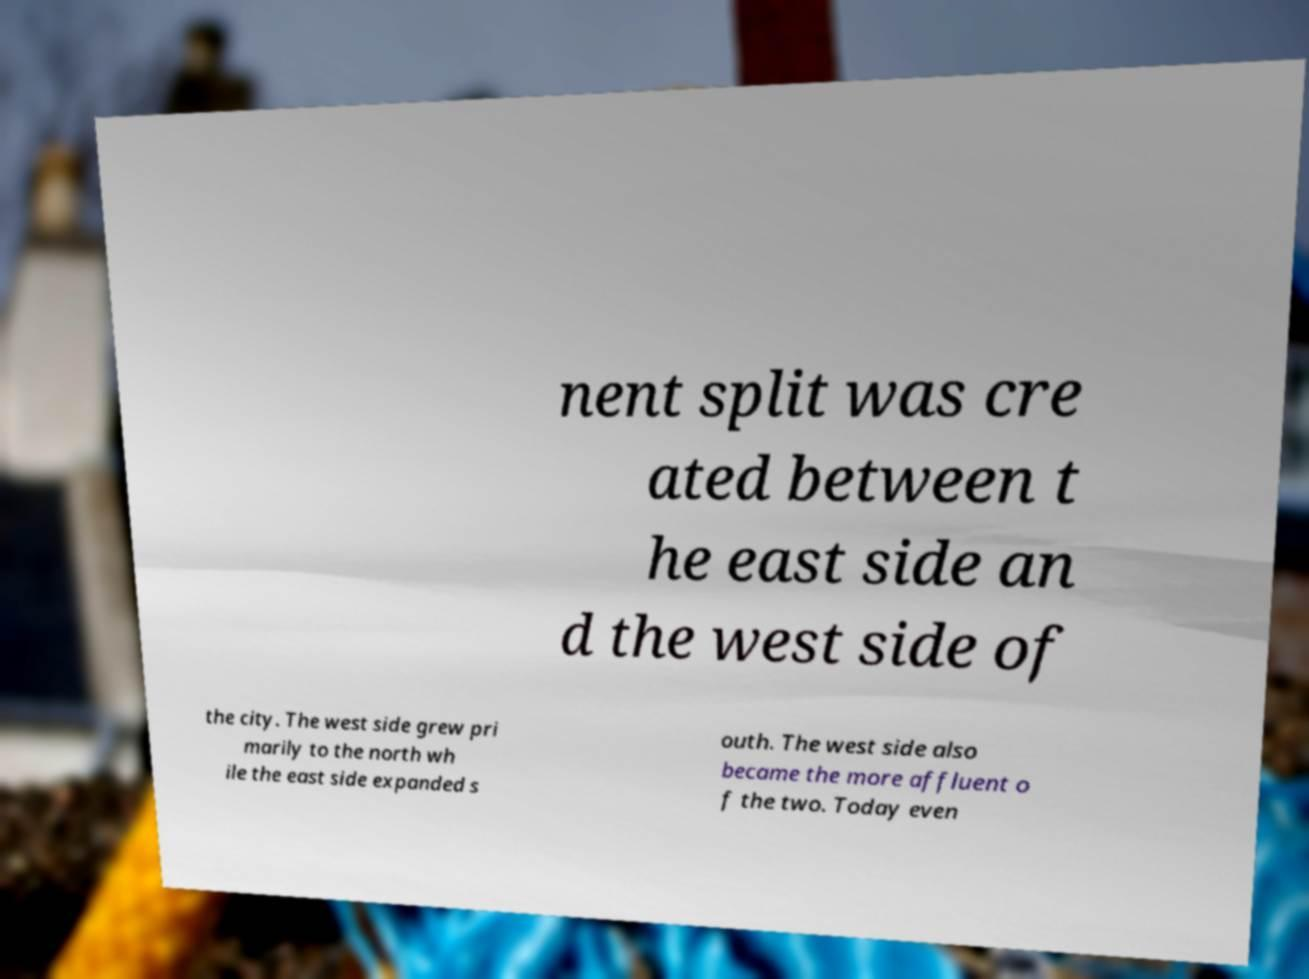Please identify and transcribe the text found in this image. nent split was cre ated between t he east side an d the west side of the city. The west side grew pri marily to the north wh ile the east side expanded s outh. The west side also became the more affluent o f the two. Today even 